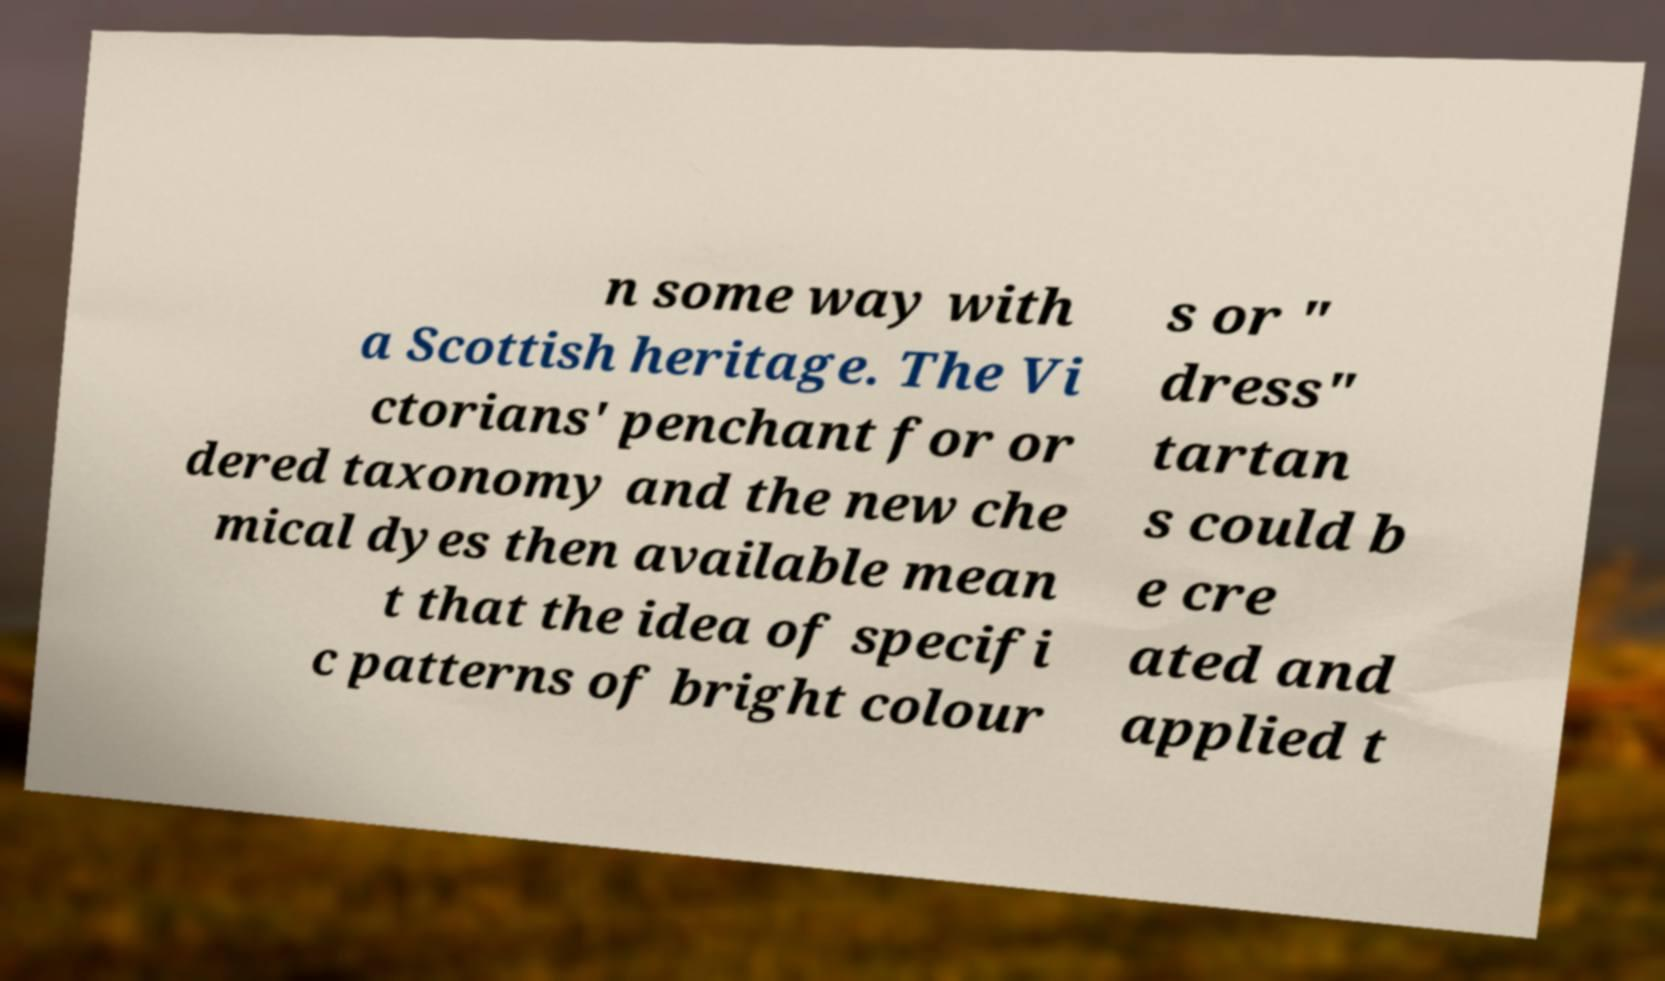Can you accurately transcribe the text from the provided image for me? n some way with a Scottish heritage. The Vi ctorians' penchant for or dered taxonomy and the new che mical dyes then available mean t that the idea of specifi c patterns of bright colour s or " dress" tartan s could b e cre ated and applied t 